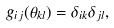Convert formula to latex. <formula><loc_0><loc_0><loc_500><loc_500>g _ { i j } ( \theta _ { k l } ) = \delta _ { i k } \delta _ { j l } ,</formula> 